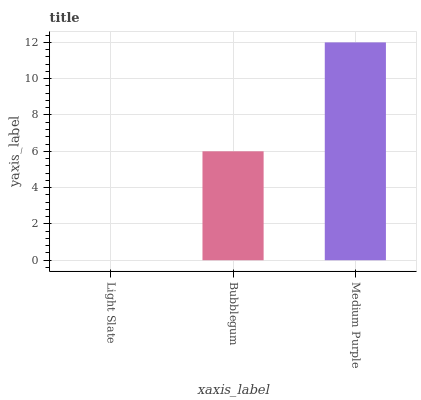Is Light Slate the minimum?
Answer yes or no. Yes. Is Medium Purple the maximum?
Answer yes or no. Yes. Is Bubblegum the minimum?
Answer yes or no. No. Is Bubblegum the maximum?
Answer yes or no. No. Is Bubblegum greater than Light Slate?
Answer yes or no. Yes. Is Light Slate less than Bubblegum?
Answer yes or no. Yes. Is Light Slate greater than Bubblegum?
Answer yes or no. No. Is Bubblegum less than Light Slate?
Answer yes or no. No. Is Bubblegum the high median?
Answer yes or no. Yes. Is Bubblegum the low median?
Answer yes or no. Yes. Is Light Slate the high median?
Answer yes or no. No. Is Medium Purple the low median?
Answer yes or no. No. 